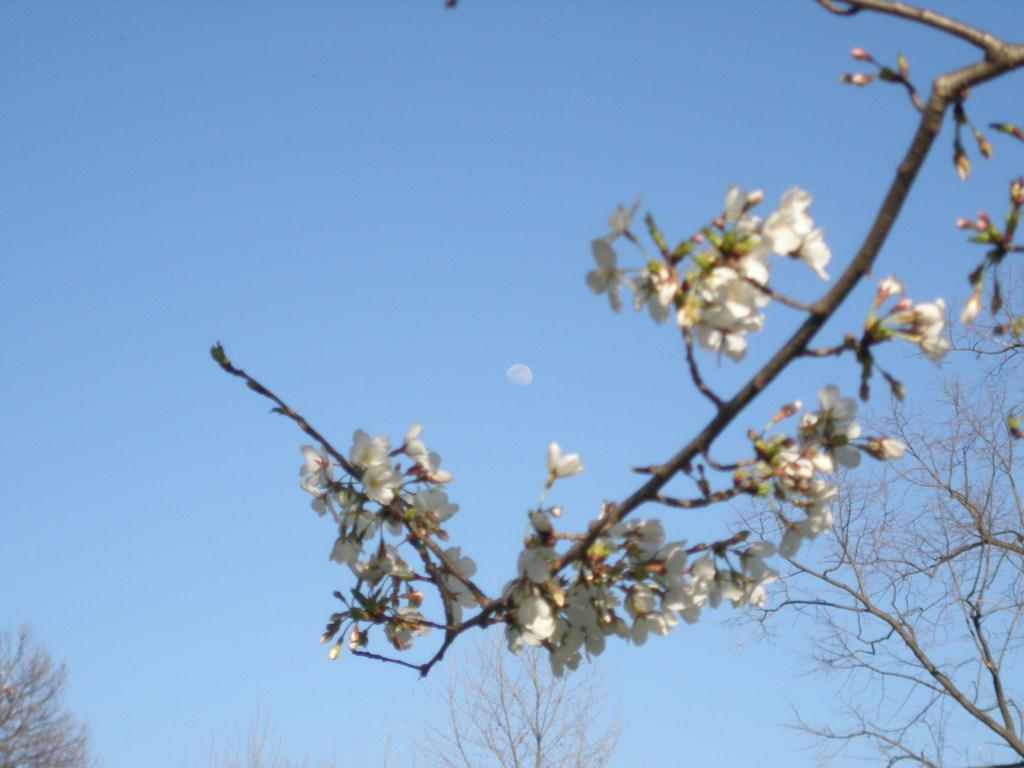What is in the foreground of the picture? There are flowers and stems in the foreground of the picture. What can be seen in the center of the picture? There are trees in the center of the picture. What is visible in the background of the picture? The background of the picture is the sky. What is located in the center of the sky? There is an object in the center of the sky. What type of yard can be seen in the picture? There is: There is no yard present in the image; it features flowers, stems, trees, and the sky. Can you tell me how many spoons are hanging from the tree in the picture? There are no spoons present in the image; it features flowers, stems, trees, and the sky. 